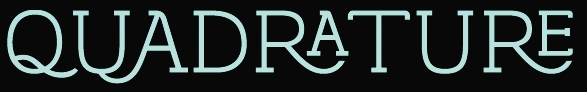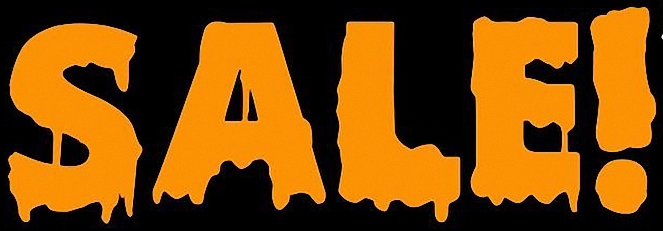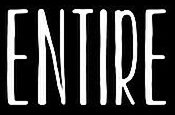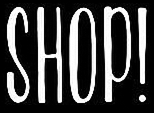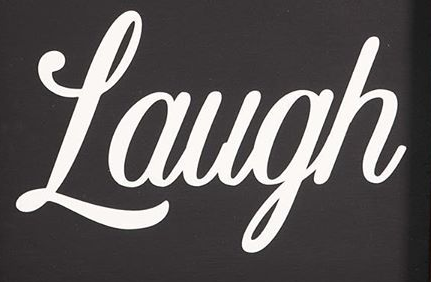What text appears in these images from left to right, separated by a semicolon? QUADRATURE; SALE!; ENTIRE; SHOP!; Laugh 